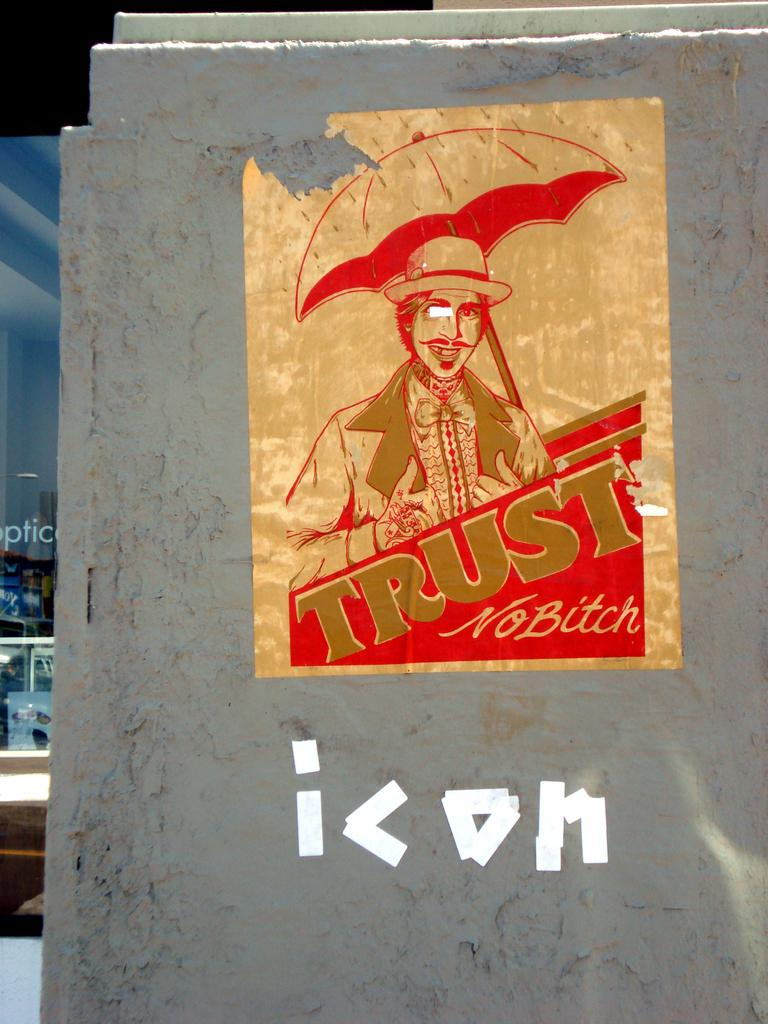Provide a one-sentence caption for the provided image. The poster features a man carrying an umbrella and the words Trust No Bitch. 